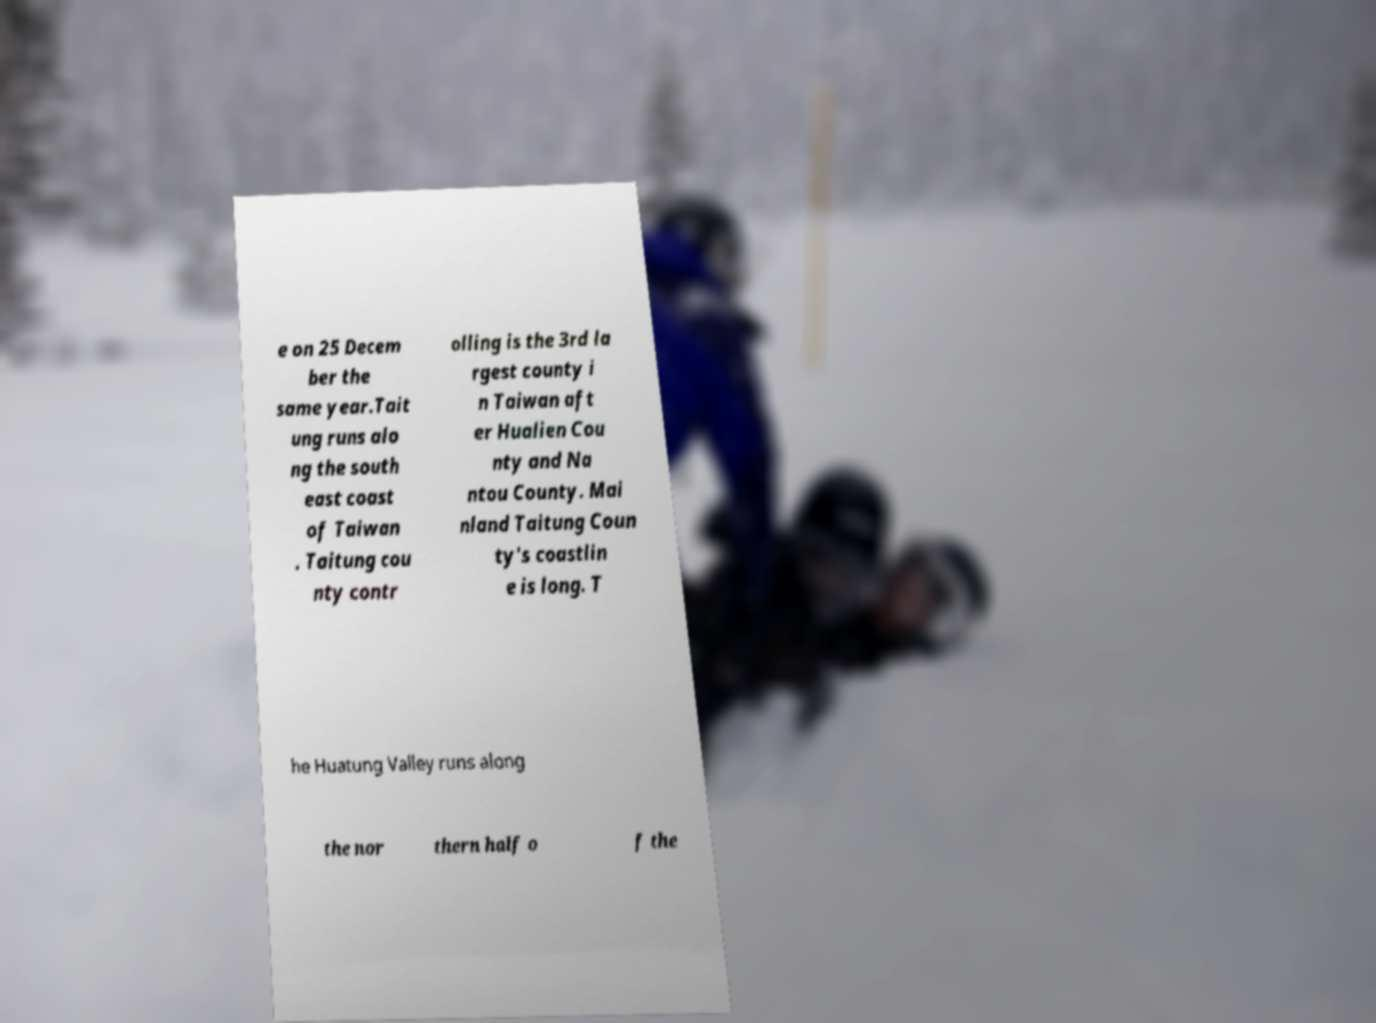There's text embedded in this image that I need extracted. Can you transcribe it verbatim? e on 25 Decem ber the same year.Tait ung runs alo ng the south east coast of Taiwan . Taitung cou nty contr olling is the 3rd la rgest county i n Taiwan aft er Hualien Cou nty and Na ntou County. Mai nland Taitung Coun ty's coastlin e is long. T he Huatung Valley runs along the nor thern half o f the 